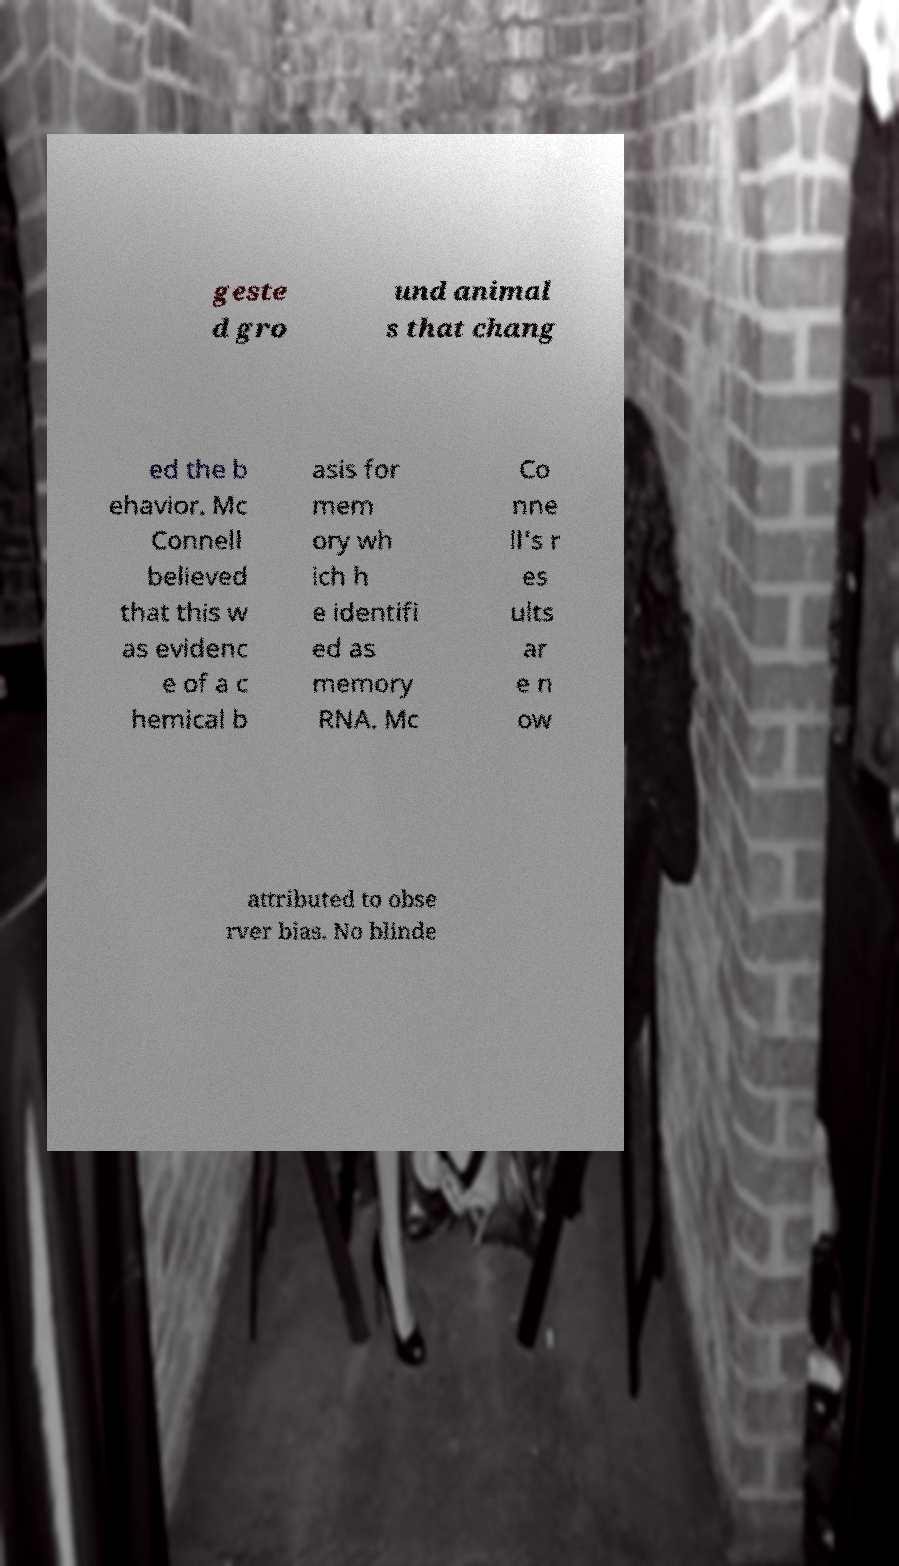Could you extract and type out the text from this image? geste d gro und animal s that chang ed the b ehavior. Mc Connell believed that this w as evidenc e of a c hemical b asis for mem ory wh ich h e identifi ed as memory RNA. Mc Co nne ll's r es ults ar e n ow attributed to obse rver bias. No blinde 